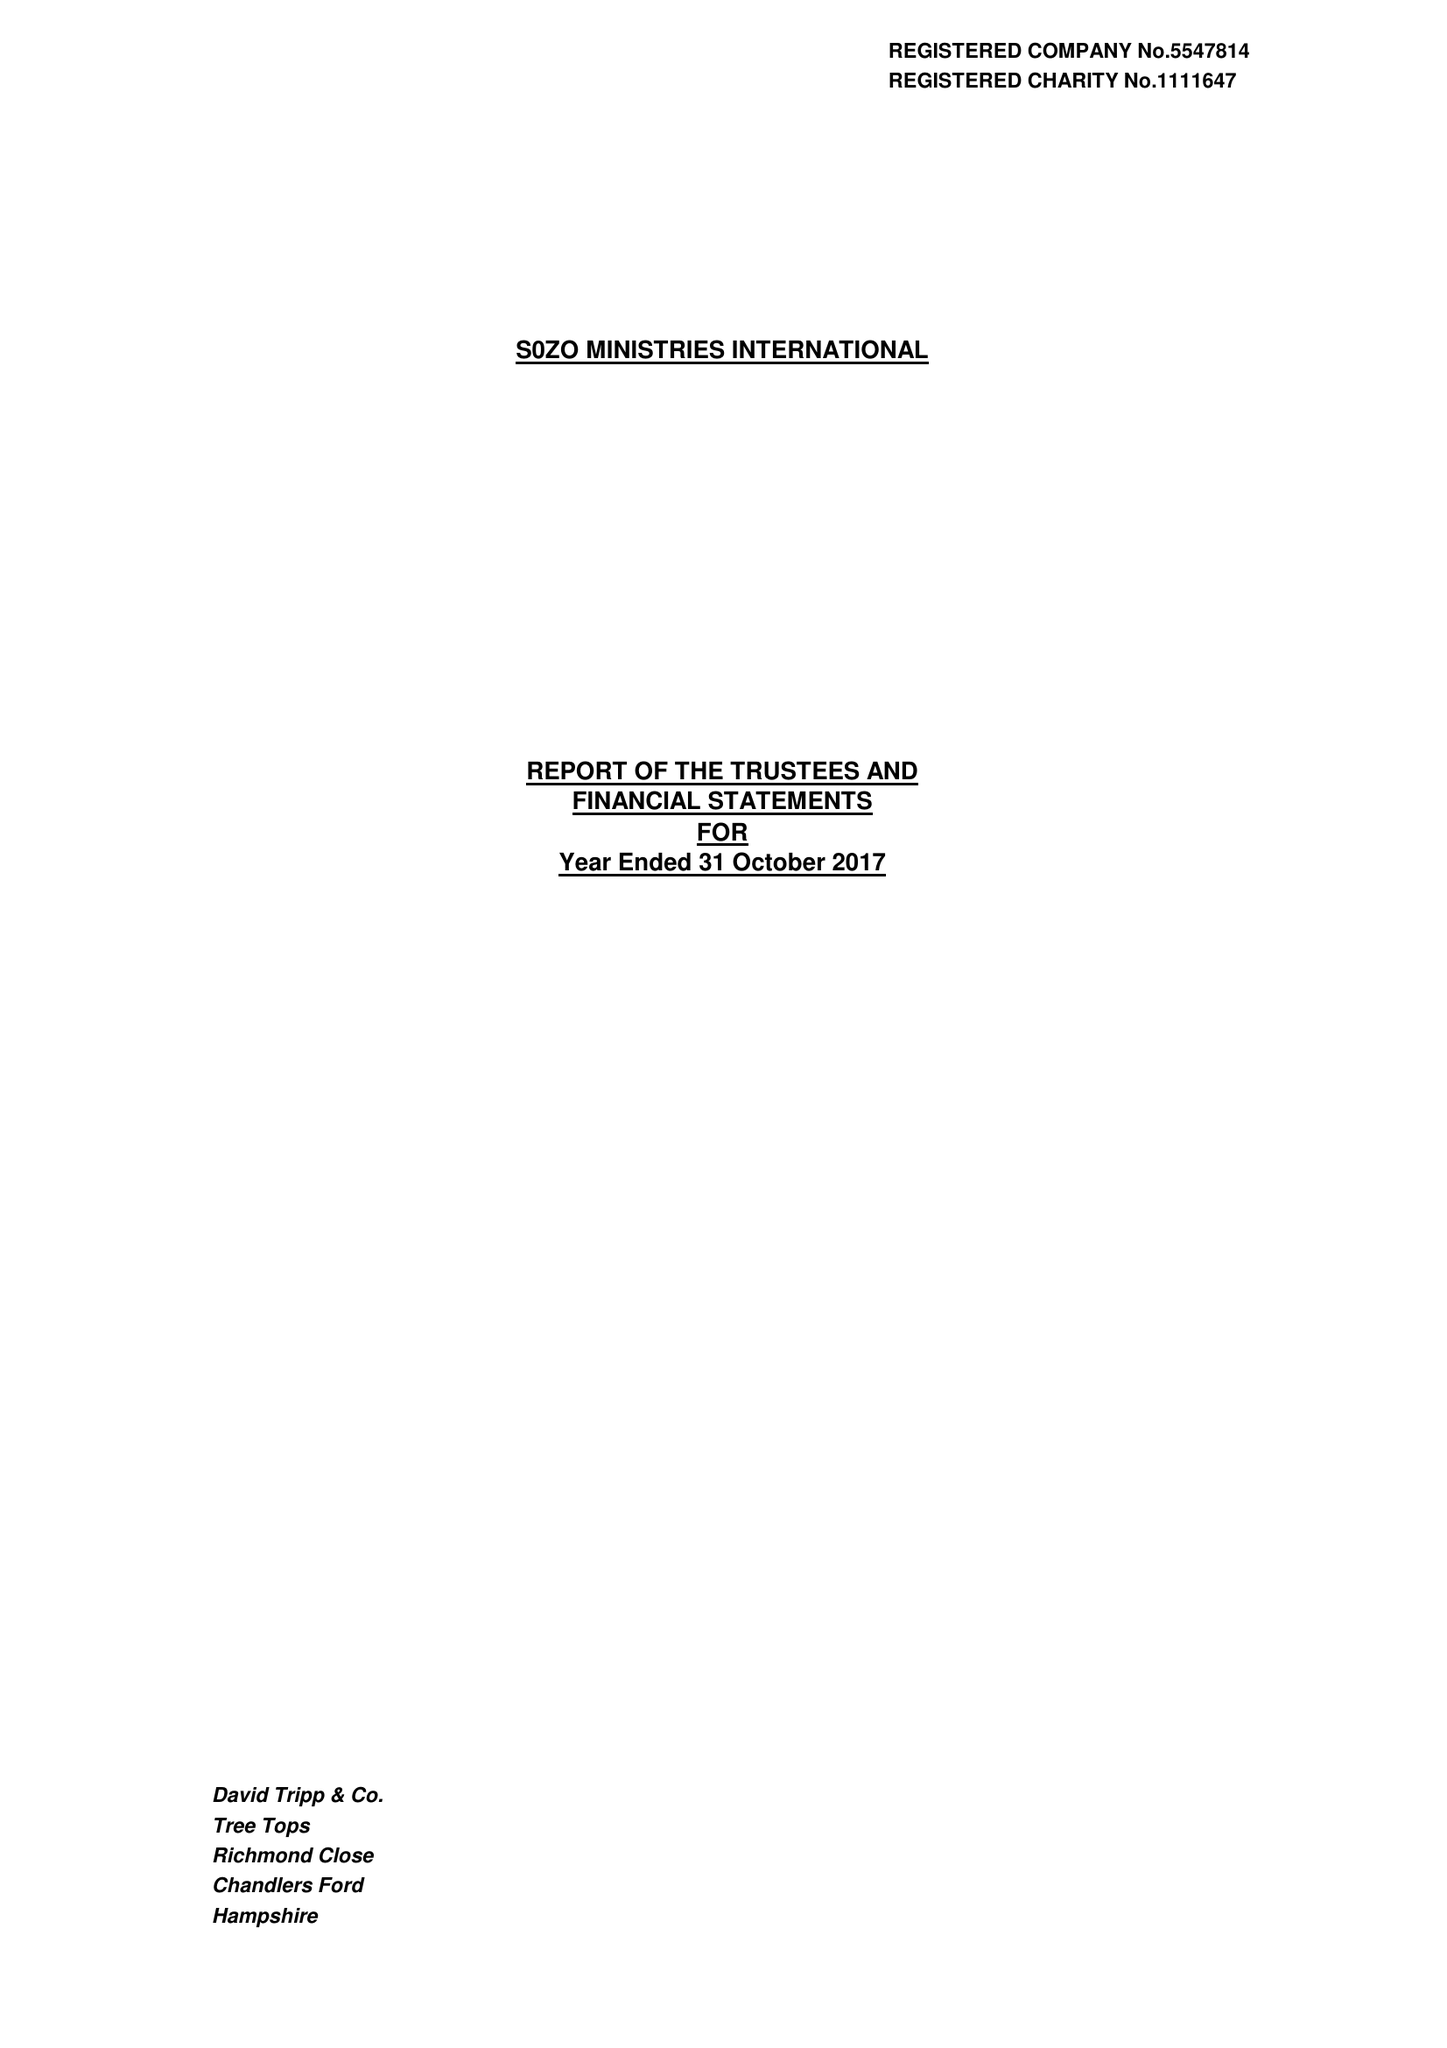What is the value for the address__postcode?
Answer the question using a single word or phrase. SO51 0GF 